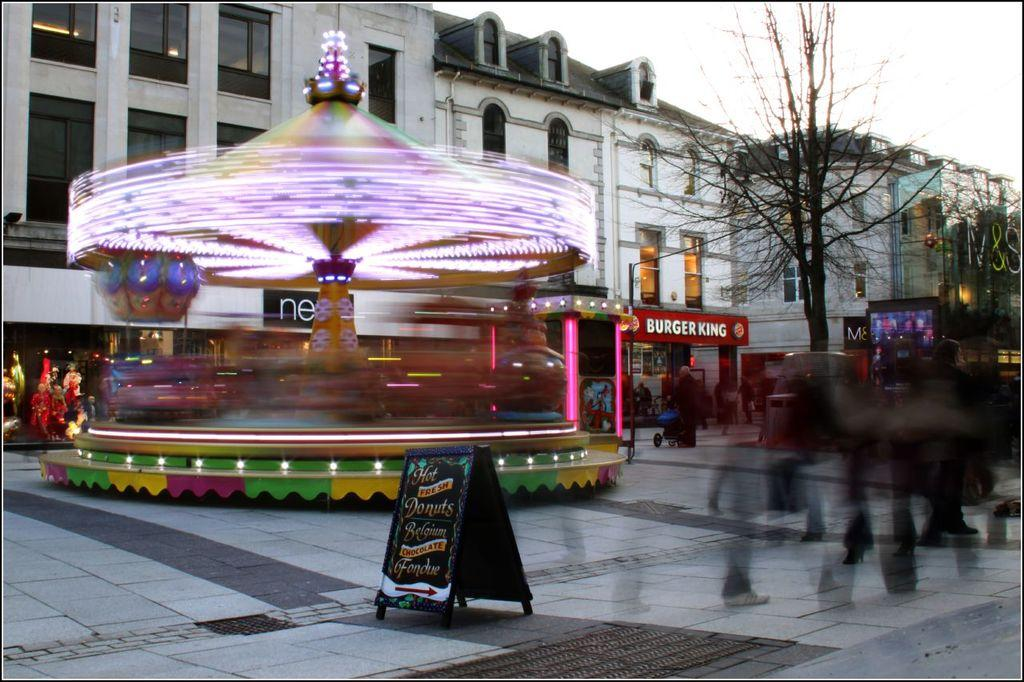Provide a one-sentence caption for the provided image. A spinning lit up carousel goes around in front of a number of businesses including a Burger King. 